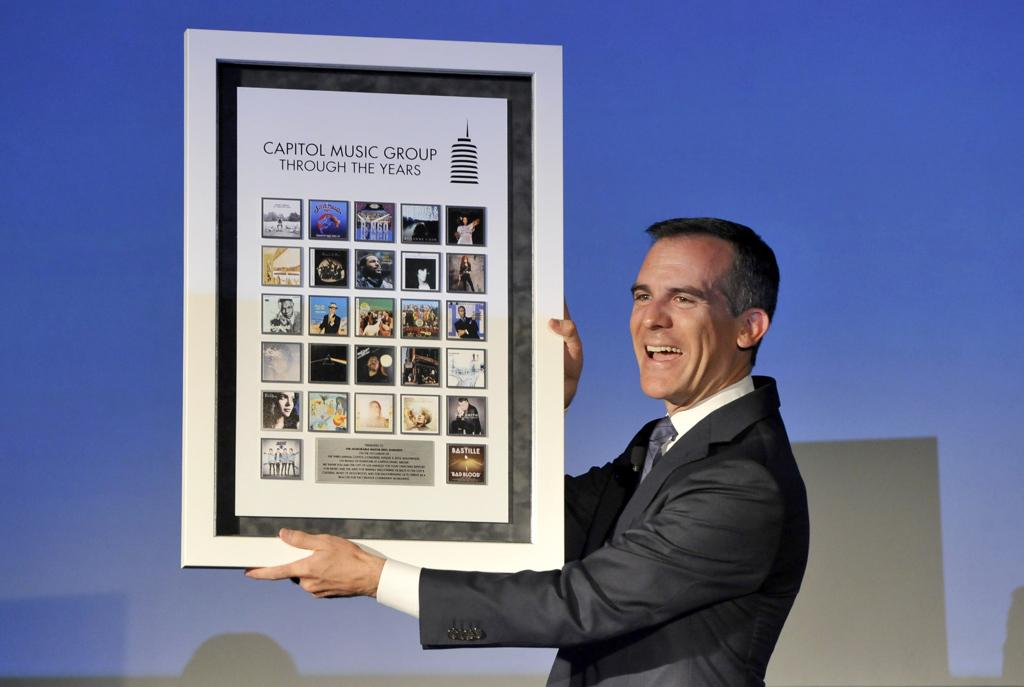<image>
Summarize the visual content of the image. A man holding up a large framed picture that says Capitol Music Group Through The Years. 